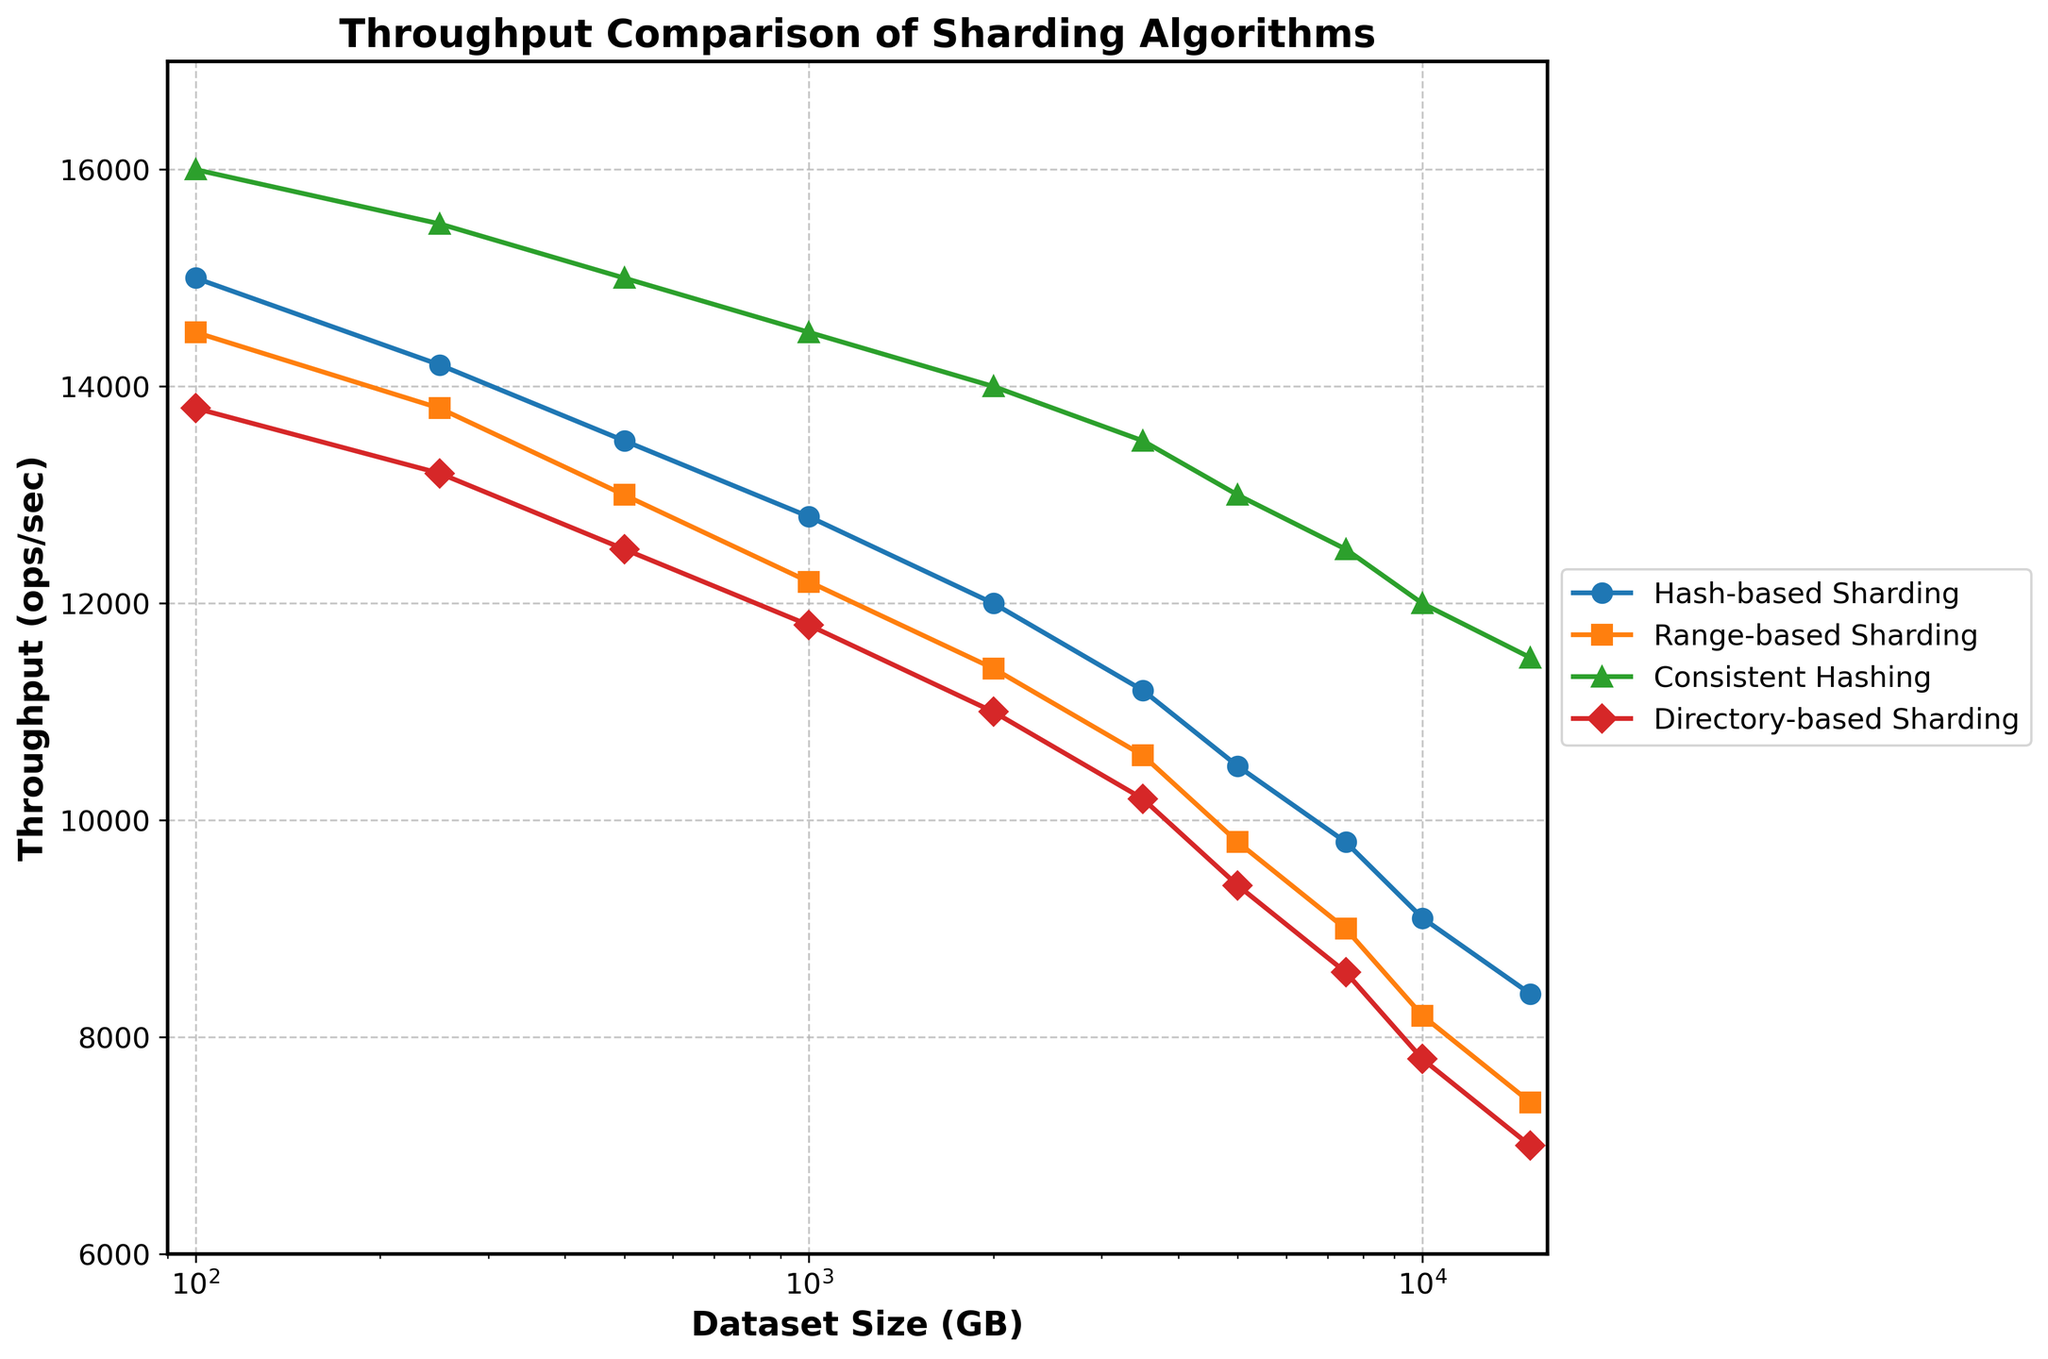What is the overall trend of throughput for all sharding algorithms as the dataset size increases? The throughput for all sharding algorithms decreases as the dataset size increases. This is evident as the lines for each algorithm slope downward from left to right.
Answer: Decreasing Which sharding algorithm maintains the highest throughput at a dataset size of 250 GB? At 250 GB, the highest line corresponds to Consistent Hashing, indicating it has the highest throughput.
Answer: Consistent Hashing How does the throughput of Directory-based Sharding compare to Hash-based Sharding at a dataset size of 5000 GB? The line for Directory-based Sharding is lower than the line for Hash-based Sharding at 5000 GB. Therefore, Directory-based Sharding has a lower throughput.
Answer: Hash-based Sharding has a higher throughput At which dataset size does Hash-based Sharding first drop below 10,000 ops/sec? By examining the plot, Hash-based Sharding first drops below 10,000 ops/sec at 7500 GB.
Answer: 7500 GB Compare the throughput trend of Range-based Sharding to Hash-based Sharding between 250 GB and 7500 GB. Both Range-based Sharding and Hash-based Sharding show a declining trend in throughput between 250 GB and 7500 GB. However, Hash-based Sharding maintains a higher throughput compared to Range-based Sharding across this range.
Answer: Hash-based Sharding maintains higher throughput; both decline What color represents Consistent Hashing in the plot? The line representing Consistent Hashing is colored green in the plot.
Answer: Green 